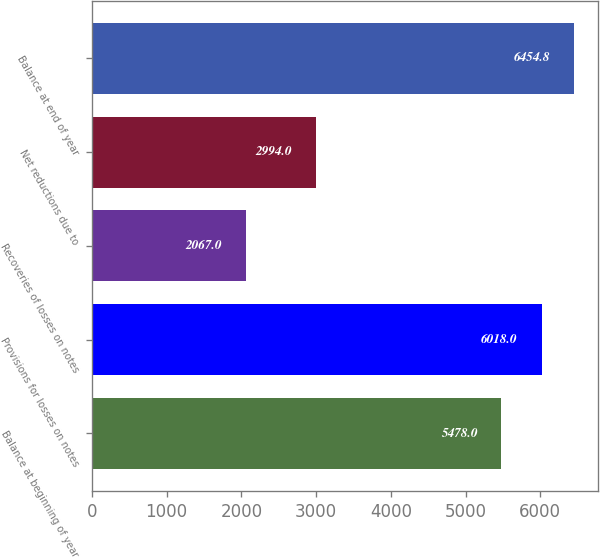<chart> <loc_0><loc_0><loc_500><loc_500><bar_chart><fcel>Balance at beginning of year<fcel>Provisions for losses on notes<fcel>Recoveries of losses on notes<fcel>Net reductions due to<fcel>Balance at end of year<nl><fcel>5478<fcel>6018<fcel>2067<fcel>2994<fcel>6454.8<nl></chart> 